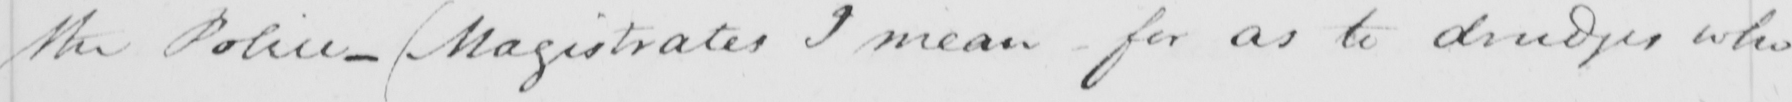Can you read and transcribe this handwriting? the Police-Magistrates I mean - for as to drudges who 